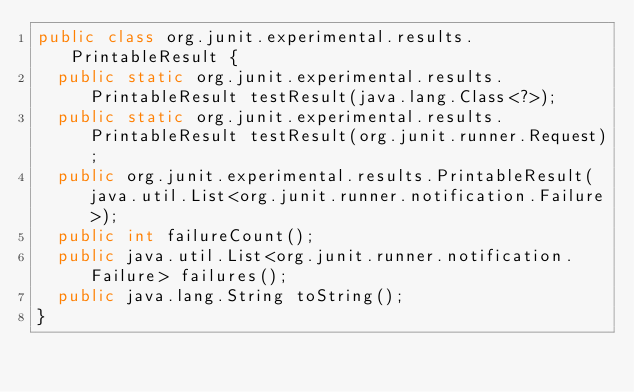<code> <loc_0><loc_0><loc_500><loc_500><_Java_>public class org.junit.experimental.results.PrintableResult {
  public static org.junit.experimental.results.PrintableResult testResult(java.lang.Class<?>);
  public static org.junit.experimental.results.PrintableResult testResult(org.junit.runner.Request);
  public org.junit.experimental.results.PrintableResult(java.util.List<org.junit.runner.notification.Failure>);
  public int failureCount();
  public java.util.List<org.junit.runner.notification.Failure> failures();
  public java.lang.String toString();
}
</code> 